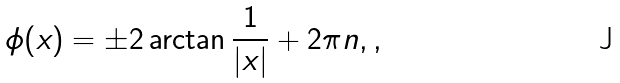<formula> <loc_0><loc_0><loc_500><loc_500>\phi ( x ) = \pm 2 \arctan \frac { 1 } { | x | } + 2 \pi n , ,</formula> 